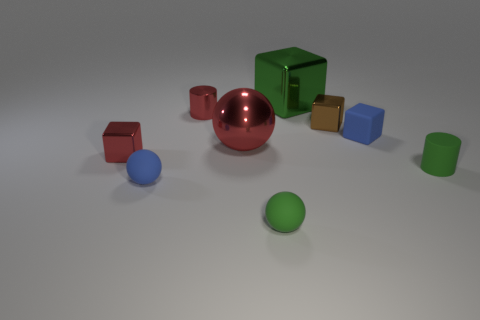Does the blue matte cube on the right side of the red metallic cylinder have the same size as the sphere that is behind the small red shiny block?
Provide a succinct answer. No. Are there any metallic things in front of the small brown shiny thing?
Offer a terse response. Yes. What is the color of the cylinder on the right side of the small metal block on the right side of the large red sphere?
Keep it short and to the point. Green. Is the number of green metal things less than the number of tiny spheres?
Keep it short and to the point. Yes. What number of rubber objects have the same shape as the green metal object?
Keep it short and to the point. 1. The metal block that is the same size as the red metallic sphere is what color?
Your answer should be very brief. Green. Are there the same number of balls behind the tiny blue matte ball and red cylinders behind the small blue cube?
Give a very brief answer. Yes. Is there a green metal thing of the same size as the red shiny block?
Offer a terse response. No. How big is the green block?
Offer a very short reply. Large. Is the number of tiny green rubber spheres behind the small blue sphere the same as the number of yellow matte spheres?
Provide a short and direct response. Yes. 